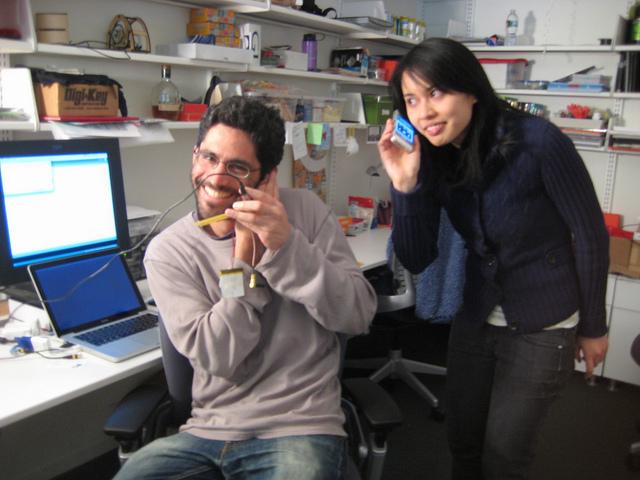How many people have glasses?
Concise answer only. 1. What brand of smartphone is in the ad?
Answer briefly. Iphone. How many dictionaries are in the photo?
Keep it brief. 0. What hand does the woman hold her cell phone in?
Concise answer only. Right. Is the woman wearing glasses?
Concise answer only. No. Are they comparing their phones?
Write a very short answer. No. Are they in an office?
Keep it brief. Yes. 